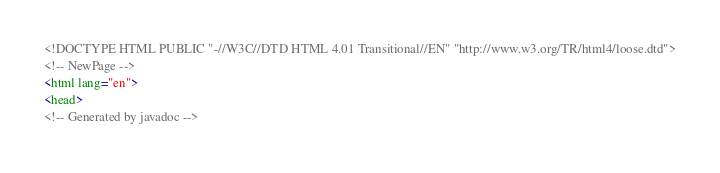Convert code to text. <code><loc_0><loc_0><loc_500><loc_500><_HTML_><!DOCTYPE HTML PUBLIC "-//W3C//DTD HTML 4.01 Transitional//EN" "http://www.w3.org/TR/html4/loose.dtd">
<!-- NewPage -->
<html lang="en">
<head>
<!-- Generated by javadoc --></code> 